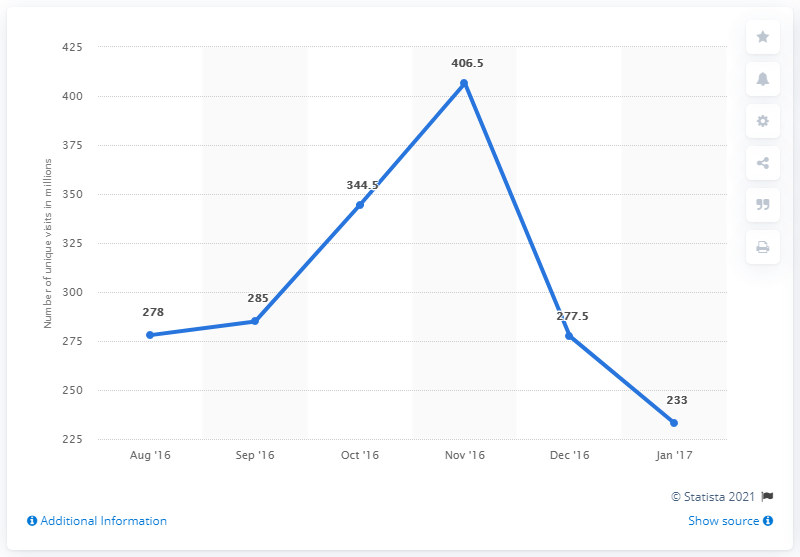Point out several critical features in this image. The sum of the first and last data points in the chart is 511. In December 2016, Tmall received a total of 277.5 unique visitors. The highest value in the chart is 406.5. 